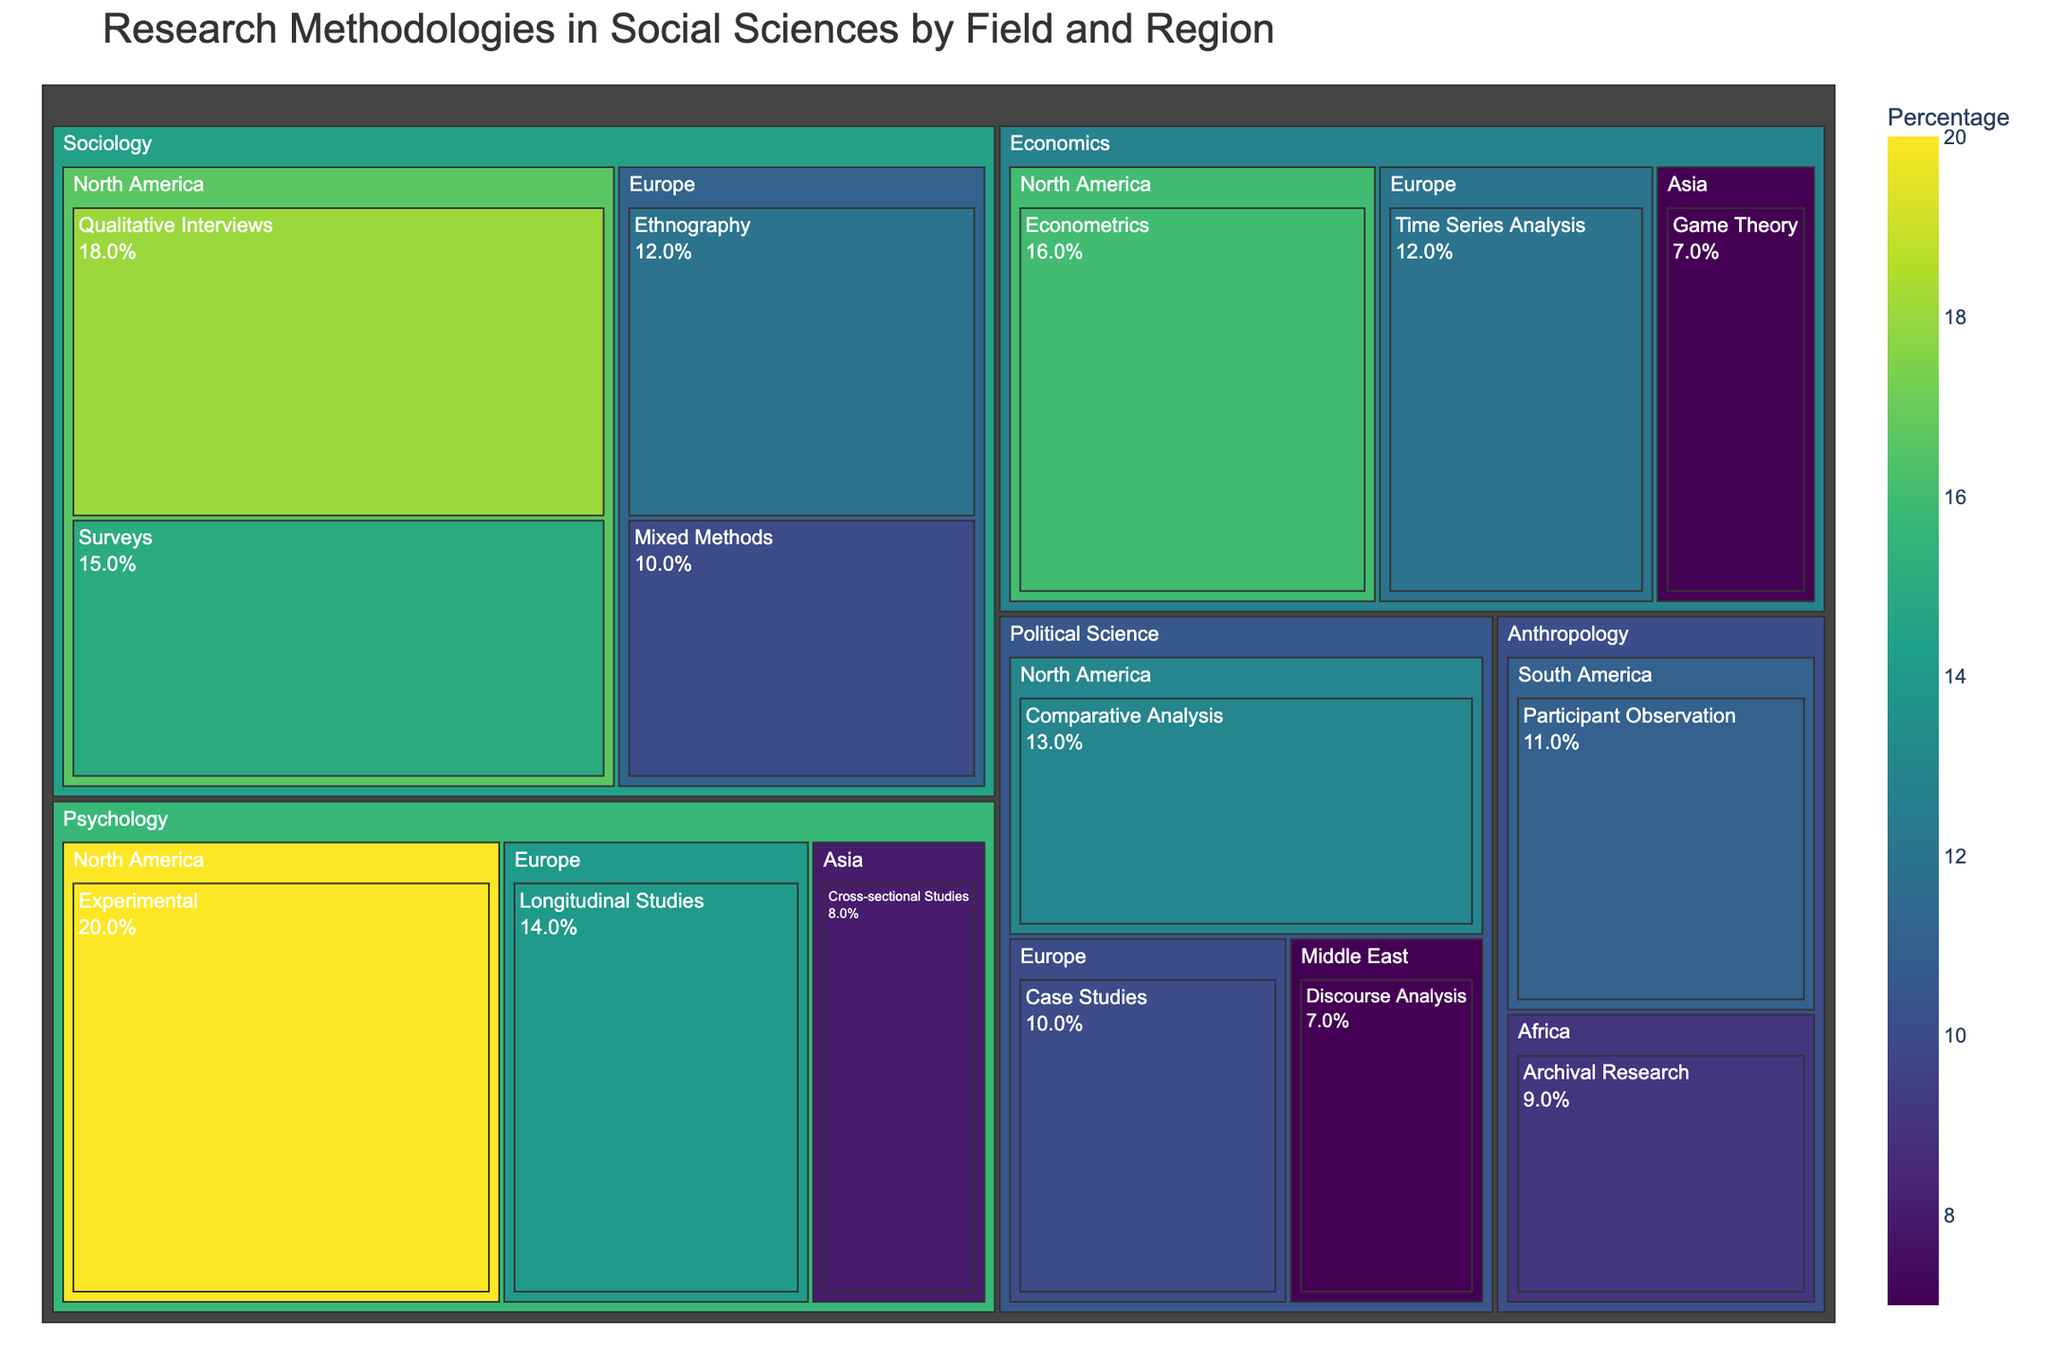What is the title of the treemap? The title is a text element located at the top of the treemap that provides an overview of the visualized data. The title helps users to understand the main topic of the figure.
Answer: Research Methodologies in Social Sciences by Field and Region Which field has the highest percentage of research methodology in North America? Look for the field nodes within the North America region and identify the one with the largest percentage. The highest percentage value belongs to Psychology with Experimental methodology.
Answer: Psychology How does the percentage of Econometrics in North America compare with Time Series Analysis in Europe? Identify and compare the percentages of Econometrics in North America and Time Series Analysis in Europe. Econometrics in North America is 16%, and Time Series Analysis in Europe is 12%.
Answer: Econometrics is higher What is the total percentage for Sociology methodologies employed in North America? Sum the percentages of all Sociology methodologies in North America: 18% for Qualitative Interviews and 15% for Surveys.
Answer: 33% Which region in Anthropology has the least percentage of research methodology represented? Look at the regions listed under the Anthropology field and identify the one with the smallest percentage. Archival Research in Africa has a percentage of 9%, which is less than Participant Observation in South America with 11%.
Answer: Africa What is the percentage difference between Experimental methodology in Psychology (North America) and Cross-sectional Studies in Psychology (Asia)? Subtract the percentage of Cross-sectional Studies in Psychology (8%) in Asia from the percentage of Experimental methodology in Psychology (20%) in North America.
Answer: 12% Which field employs Mixed Methods in Europe and what is its percentage? Identify the field that includes Mixed Methods within the Europe region and note the percentage value. Sociology employs Mixed Methods in Europe at 10%.
Answer: Sociology, 10% If you combine the percentages of Game Theory in Asia and Discourse Analysis in the Middle East, what is the total percentage? Add the percentages of Game Theory in Asia (7%) and Discourse Analysis in the Middle East (7%).
Answer: 14% How many distinct methodologies are represented in the treemap? Count the unique methodologies listed across all fields and regions. There are 15 unique methodologies.
Answer: 15 Which field has the most diverse set of research methodologies, and how many different methodologies does it have? Determine the field with the most unique methodologies listed under its regions. Sociology has 4 different methodologies: Qualitative Interviews, Surveys, Ethnography, and Mixed Methods.
Answer: Sociology, 4 